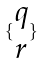<formula> <loc_0><loc_0><loc_500><loc_500>\{ \begin{matrix} q \\ r \end{matrix} \}</formula> 